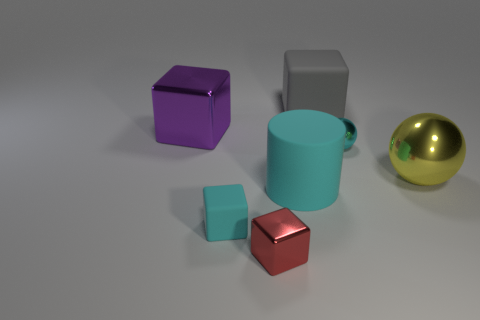Subtract all small cyan cubes. How many cubes are left? 3 Add 2 tiny cyan spheres. How many objects exist? 9 Subtract 1 cylinders. How many cylinders are left? 0 Subtract all purple cubes. How many cubes are left? 3 Subtract all tiny brown matte blocks. Subtract all purple objects. How many objects are left? 6 Add 2 large cyan cylinders. How many large cyan cylinders are left? 3 Add 2 tiny cyan blocks. How many tiny cyan blocks exist? 3 Subtract 0 gray spheres. How many objects are left? 7 Subtract all balls. How many objects are left? 5 Subtract all blue cylinders. Subtract all yellow blocks. How many cylinders are left? 1 